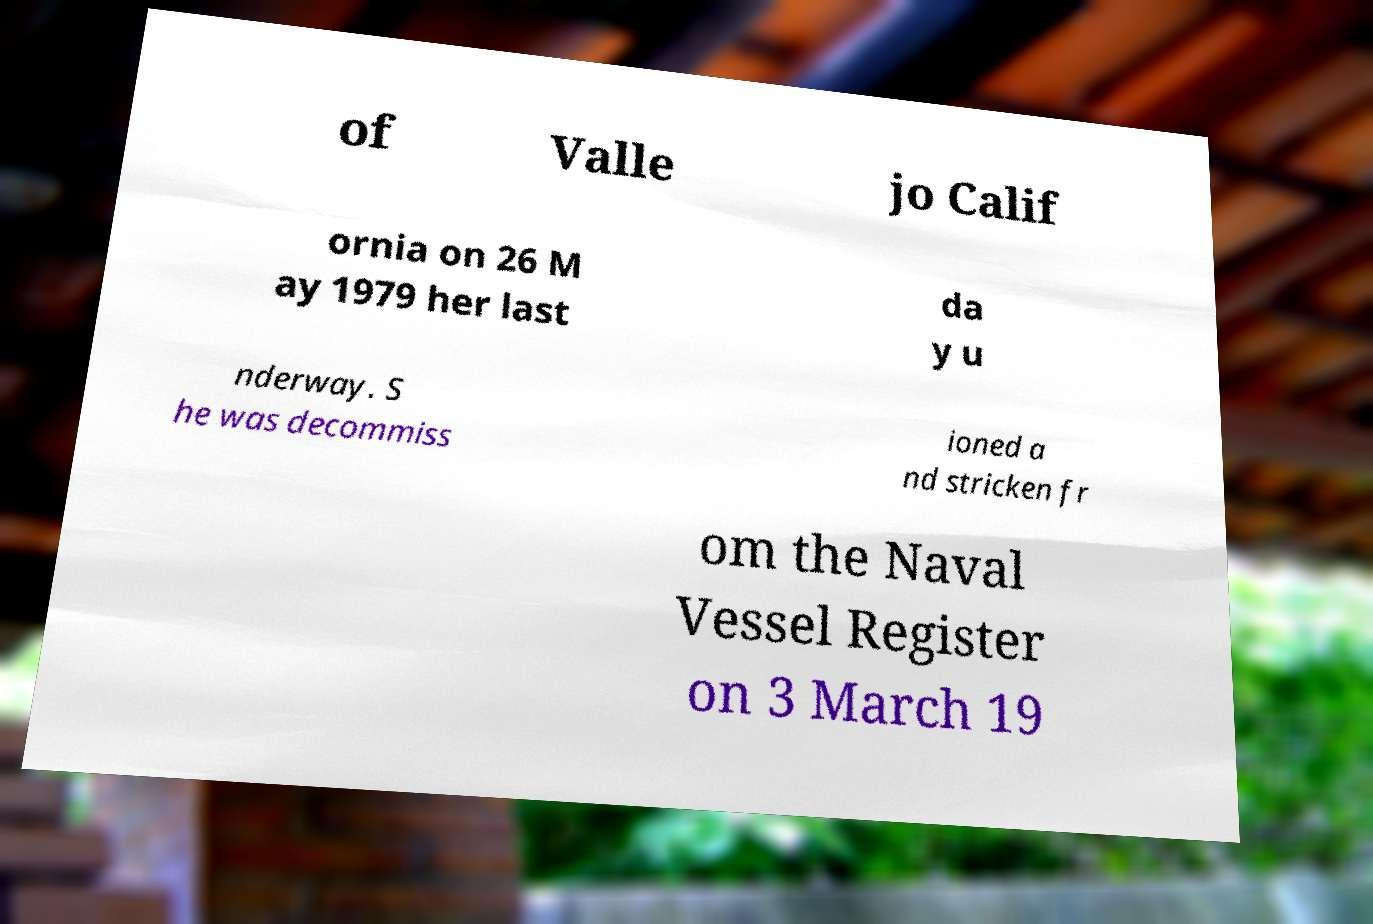I need the written content from this picture converted into text. Can you do that? of Valle jo Calif ornia on 26 M ay 1979 her last da y u nderway. S he was decommiss ioned a nd stricken fr om the Naval Vessel Register on 3 March 19 